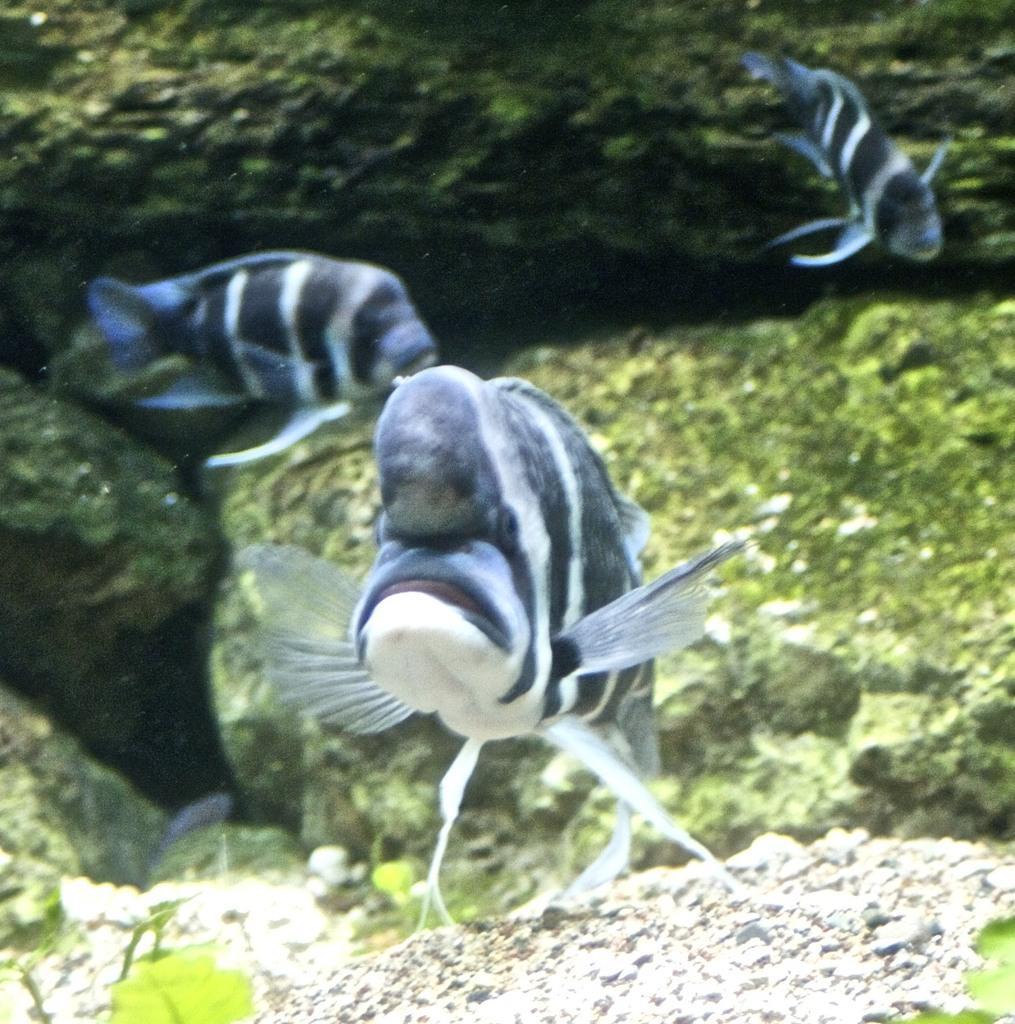Describe this image in one or two sentences. In this picture we can see fishes, green leaves and water. 